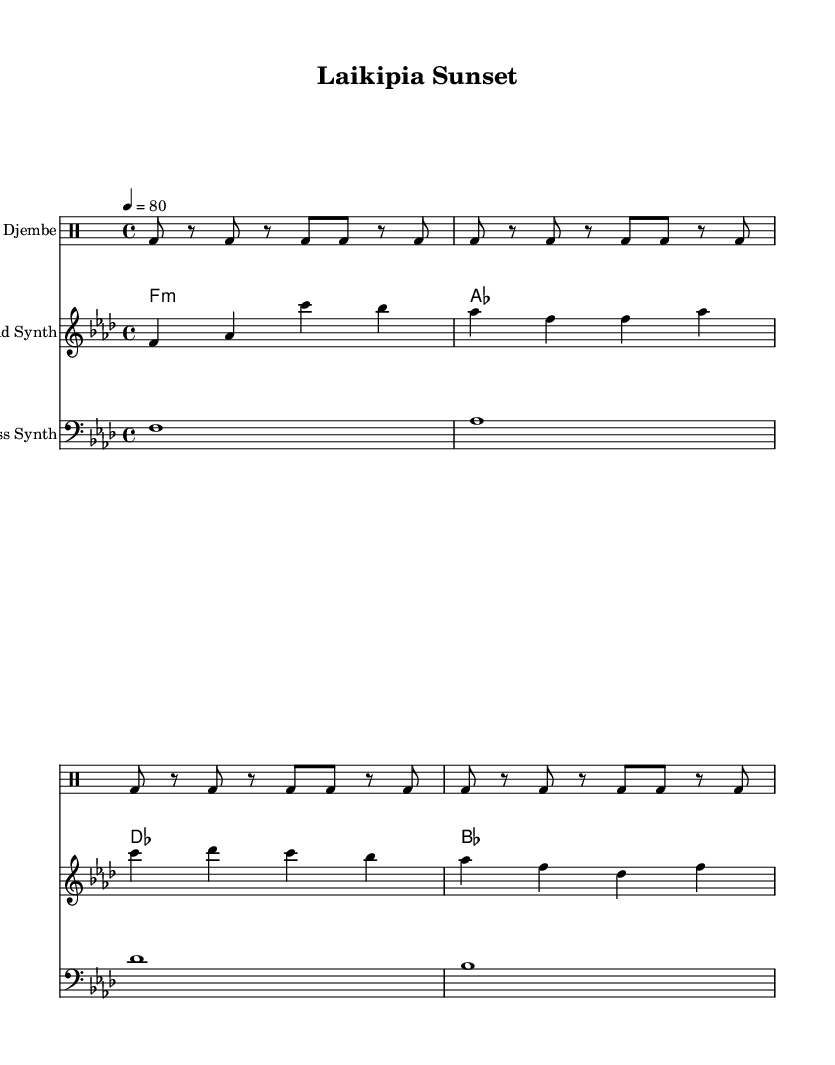What is the key signature of this music? The key signature shown is F minor, indicated by the presence of four flats in the key signature area of the sheet music.
Answer: F minor What is the time signature of this piece? The time signature is found at the beginning of the score, where it shows 4/4, meaning there are four beats in each measure, and a quarter note receives one beat.
Answer: 4/4 What is the tempo marking? The tempo is indicated at the start of the score as 4 = 80, which means there are 80 beats per minute. This specifies the speed of the piece.
Answer: 80 How many measures are in the djembe part? The djembe part consists of four repeats of the pattern, each repeat covering a measure. Therefore, there are four measures total, as indicated by the repeat indications.
Answer: 4 measures How many notes are in the lead synth part? By counting the distinct note events in the lead synth line, which consists of several quarter notes and one note rest, there are a total of 16 notes present.
Answer: 16 notes What type of synthesizer is used for the pad? The piece uses a synth pad, indicated by the "Synth Pad" label above the chord section, which suggests it provides a lush, sustained sound background for the track.
Answer: Synth Pad Which percussion instrument is featured prominently in this score? The sheet music explicitly labels the percussion part as "Djembe," a drum native to West Africa, which is crucial for the rhythm and texture of the electronic piece.
Answer: Djembe 